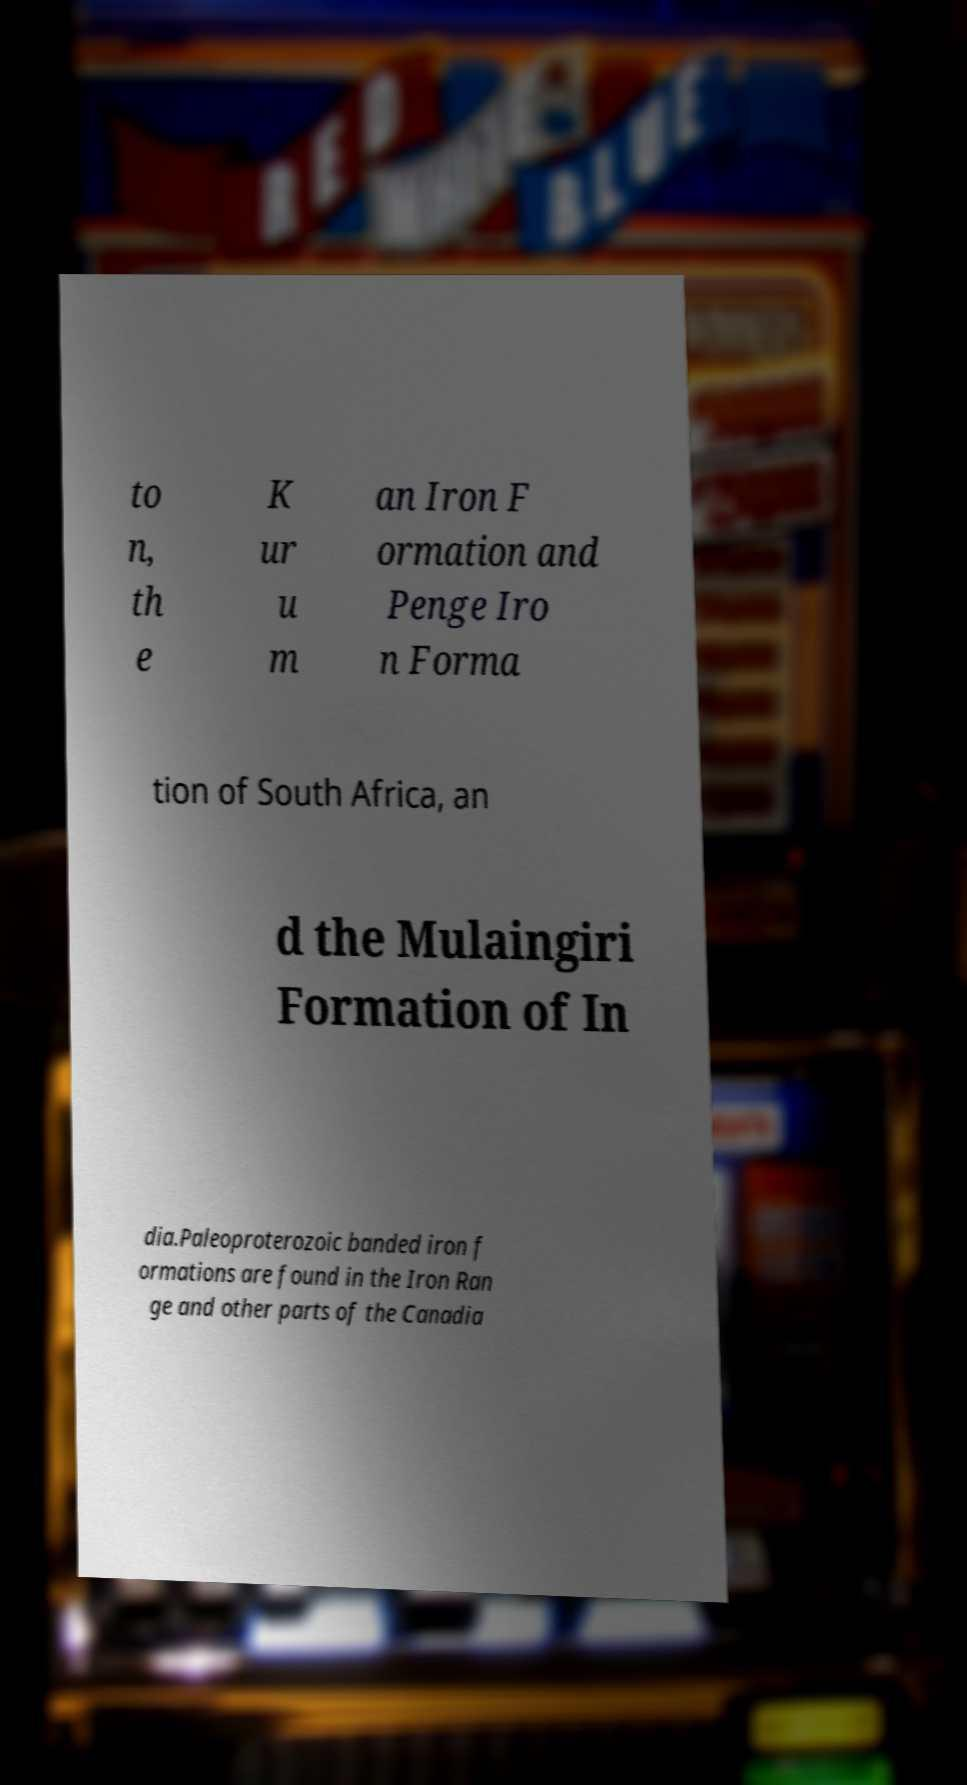Could you assist in decoding the text presented in this image and type it out clearly? to n, th e K ur u m an Iron F ormation and Penge Iro n Forma tion of South Africa, an d the Mulaingiri Formation of In dia.Paleoproterozoic banded iron f ormations are found in the Iron Ran ge and other parts of the Canadia 